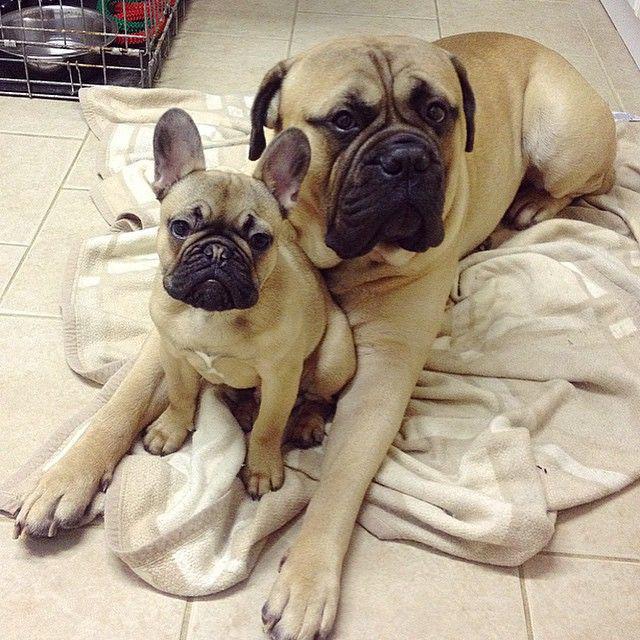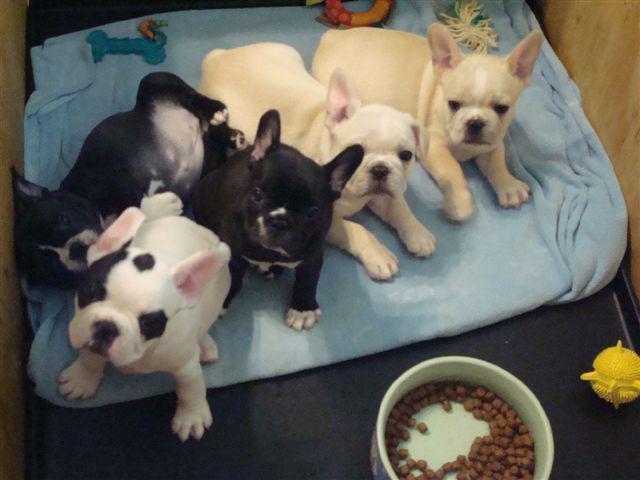The first image is the image on the left, the second image is the image on the right. Examine the images to the left and right. Is the description "Exactly six little dogs are shown." accurate? Answer yes or no. No. The first image is the image on the left, the second image is the image on the right. Assess this claim about the two images: "There are six dogs". Correct or not? Answer yes or no. No. 